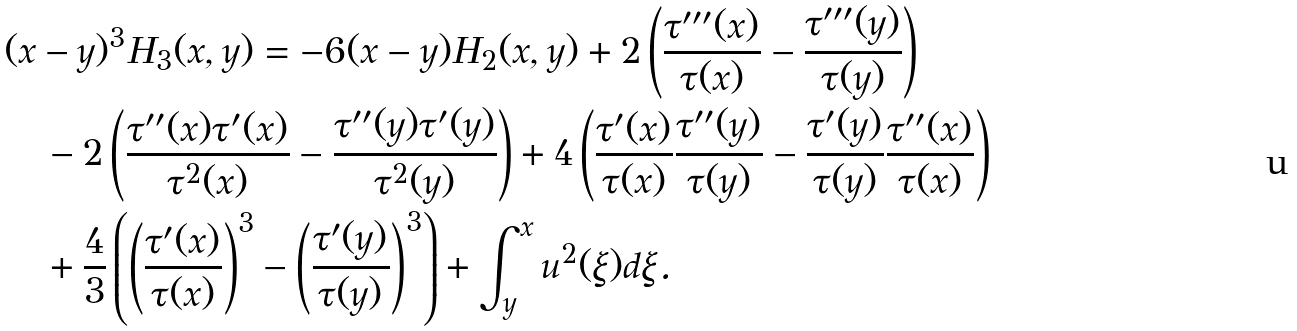Convert formula to latex. <formula><loc_0><loc_0><loc_500><loc_500>& ( x - y ) ^ { 3 } H _ { 3 } ( x , y ) = - 6 ( x - y ) H _ { 2 } ( x , y ) + 2 \left ( \frac { \tau ^ { \prime \prime \prime } ( x ) } { \tau ( x ) } - \frac { \tau ^ { \prime \prime \prime } ( y ) } { \tau ( y ) } \right ) \\ & \quad - 2 \left ( \frac { \tau ^ { \prime \prime } ( x ) \tau ^ { \prime } ( x ) } { \tau ^ { 2 } ( x ) } - \frac { \tau ^ { \prime \prime } ( y ) \tau ^ { \prime } ( y ) } { \tau ^ { 2 } ( y ) } \right ) + 4 \left ( \frac { \tau ^ { \prime } ( x ) } { \tau ( x ) } \frac { \tau ^ { \prime \prime } ( y ) } { \tau ( y ) } - \frac { \tau ^ { \prime } ( y ) } { \tau ( y ) } \frac { \tau ^ { \prime \prime } ( x ) } { \tau ( x ) } \right ) \\ & \quad + \frac { 4 } { 3 } \left ( \left ( \frac { \tau ^ { \prime } ( x ) } { \tau ( x ) } \right ) ^ { 3 } - \left ( \frac { \tau ^ { \prime } ( y ) } { \tau ( y ) } \right ) ^ { 3 } \right ) + \int _ { y } ^ { x } u ^ { 2 } ( \xi ) d \xi .</formula> 